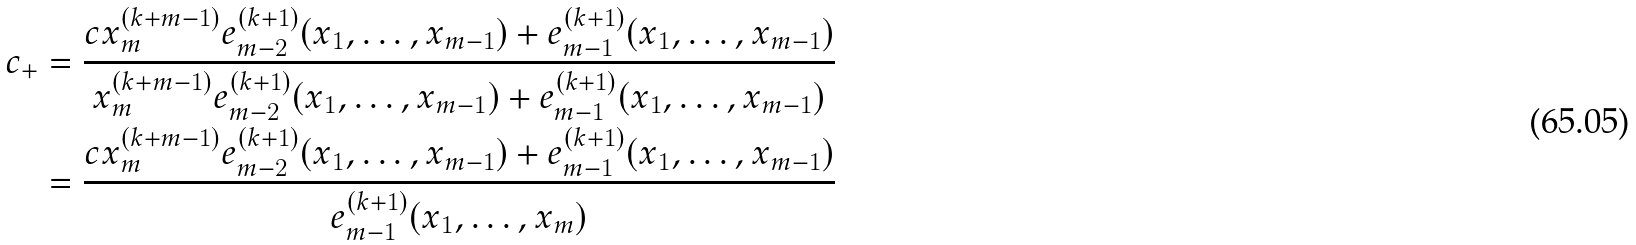<formula> <loc_0><loc_0><loc_500><loc_500>c _ { + } & = \frac { c x _ { m } ^ { ( k + m - 1 ) } e _ { m - 2 } ^ { ( k + 1 ) } ( x _ { 1 } , \dots , x _ { m - 1 } ) + e _ { m - 1 } ^ { ( k + 1 ) } ( x _ { 1 } , \dots , x _ { m - 1 } ) } { x _ { m } ^ { ( k + m - 1 ) } e _ { m - 2 } ^ { ( k + 1 ) } ( x _ { 1 } , \dots , x _ { m - 1 } ) + e _ { m - 1 } ^ { ( k + 1 ) } ( x _ { 1 } , \dots , x _ { m - 1 } ) } \\ & = \frac { c x _ { m } ^ { ( k + m - 1 ) } e _ { m - 2 } ^ { ( k + 1 ) } ( x _ { 1 } , \dots , x _ { m - 1 } ) + e _ { m - 1 } ^ { ( k + 1 ) } ( x _ { 1 } , \dots , x _ { m - 1 } ) } { e _ { m - 1 } ^ { ( k + 1 ) } ( x _ { 1 } , \dots , x _ { m } ) }</formula> 